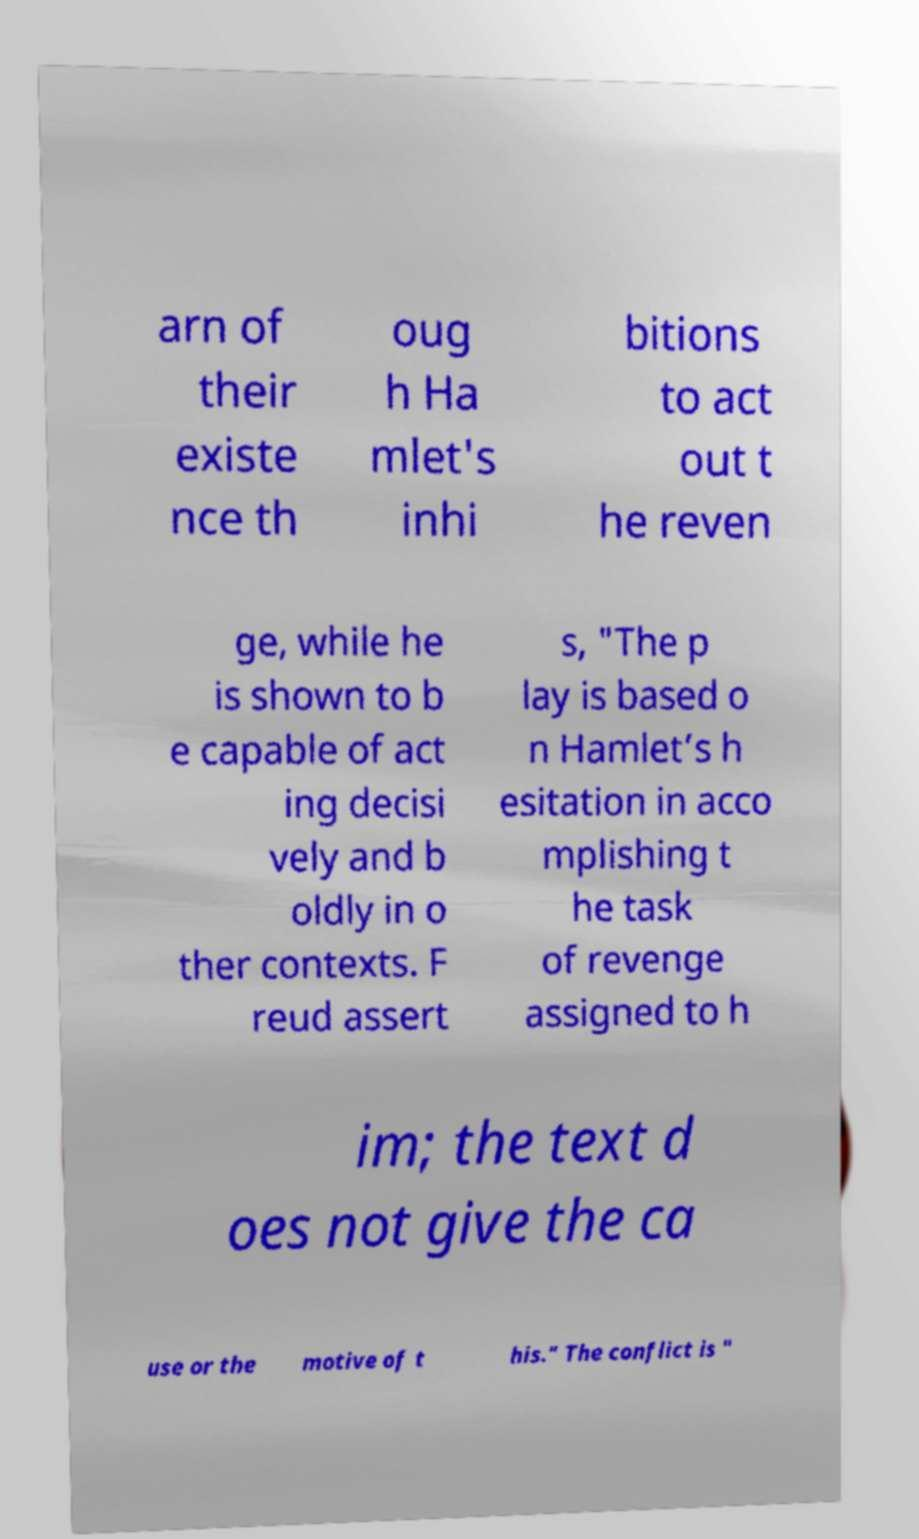Please read and relay the text visible in this image. What does it say? arn of their existe nce th oug h Ha mlet's inhi bitions to act out t he reven ge, while he is shown to b e capable of act ing decisi vely and b oldly in o ther contexts. F reud assert s, "The p lay is based o n Hamlet’s h esitation in acco mplishing t he task of revenge assigned to h im; the text d oes not give the ca use or the motive of t his." The conflict is " 